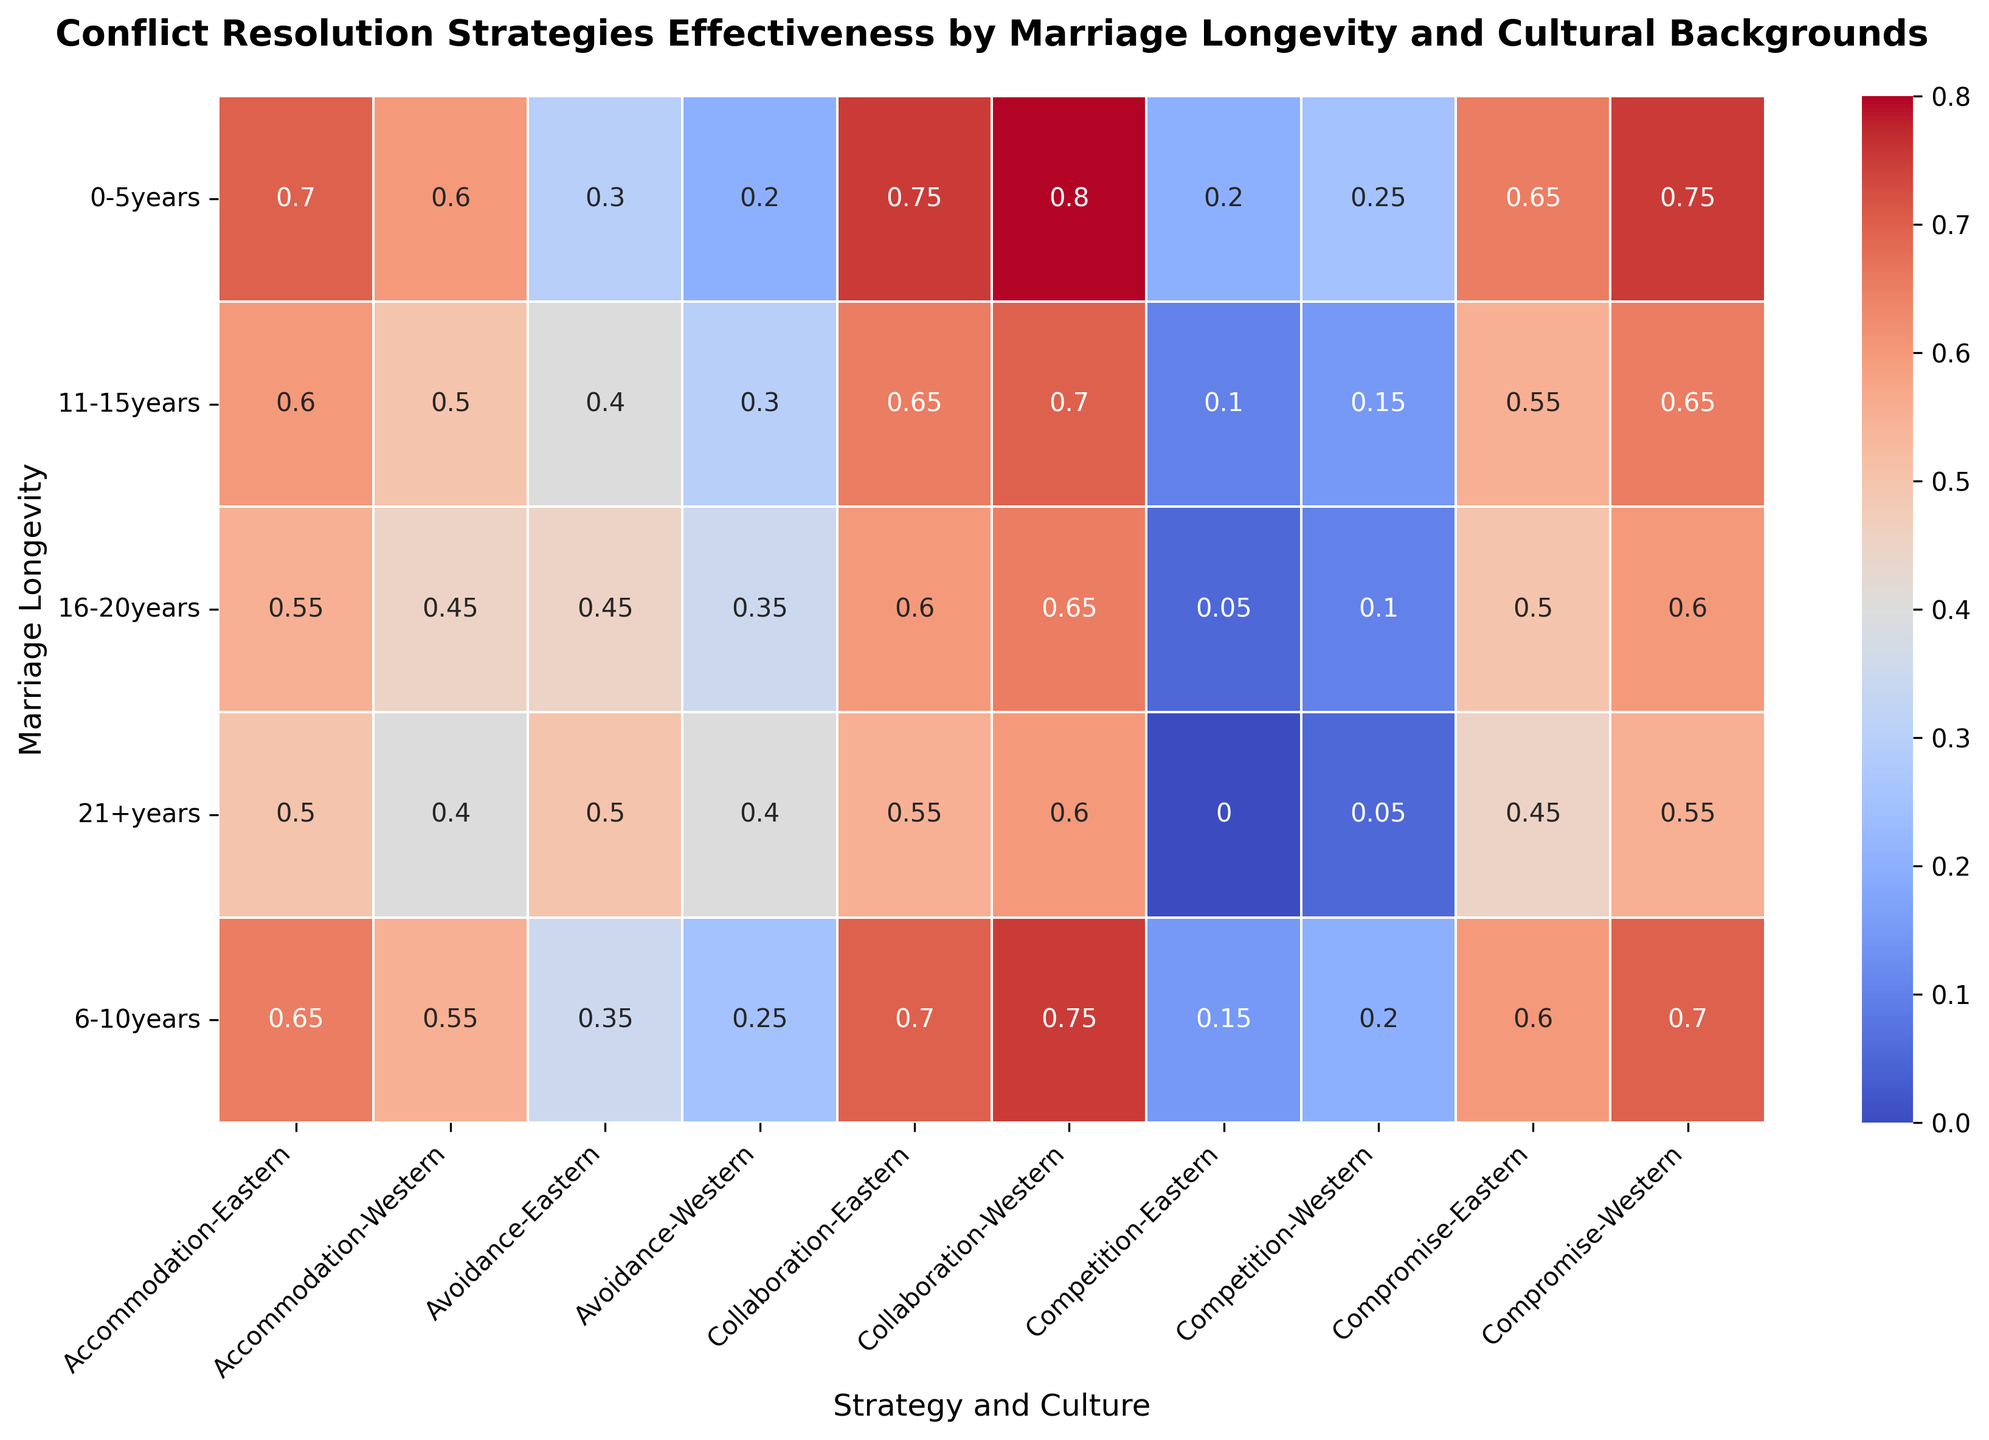what conflict resolution strategy is most effective for both Western and Eastern cultures in 0-5 years of marriage? Look at the first row of the heatmap under the category "0-5 years" for both Western and Eastern cultures. The highest value is 0.80 for Collaboration in Western culture and 0.75 for Collaboration in Eastern culture
Answer: Collaboration Which conflict resolution strategy shows a decreasing trend in effectiveness across all marriage longevities for both Western and Eastern cultures? Examine each strategy's value progression across marriage longevitites (columns) for both Western and Eastern cultures. Both Compromise and Colloboration show a consistent decrease
Answer: Compromise and Collaboration Is Avoidance more effective in later stages of marriage for Eastern culture compared to Western culture? Compare Avoidance values for 16-20 years and 21+ years columns under both cultures. 45 and 50 for Eastern culture versus 35 and 40 for Western culture
Answer: Yes Which conflict resolution strategy becomes the least effective in marriages lasting 21+ years in Eastern culture? Compare values in the "21+ years" column for all Eastern culture conflict resolution strategies. 0.00 is the lowest value for Competition
Answer: Competition What's the difference in effectiveness of the Compromise strategy between 0-5 years and 21+ years in Western culture? Subtract the value for 21+ years from the value for 0-5 years under Compromise (Western). 0.75 - 0.55 = 0.20
Answer: 0.20 Which culture relies more on Accommodation as a strategy in the earlier years of marriage? Compare Accommodation values for 0-5 years between both cultures. Western is 0.60 while Eastern is 0.70
Answer: Eastern How does the effectiveness of the Competition strategy change over time in Western culture? Look at the values of Competition (Western) across all columns. The values decrease from 0.25 to 0.05
Answer: Decreases In Eastern culture, what’s the average effectiveness of the Collaboration strategy from 11-15 years to 21+ years? Add the values and divide by the number of data points. (0.65 + 0.60 + 0.55)/3 = 1.80/3
Answer: 0.60 Which strategy under the Western culture has the smallest decrease in effectiveness between 0-5 years and 21+ years? Calculate the decrease for all strategies and compare. The smallest decrease for Western culture values is calculated as Collaboration (0.80 - 0.60 = 0.20)
Answer: Collaboration In the 6-10 years range, which strategy's effectiveness is closest between Western and Eastern cultures? Compare 6-10 years values for all strategies between Western and Eastern cultures. Compromise shows 0.70 (Western) and 0.60 (Eastern) with difference of 0.10
Answer: Compromise 